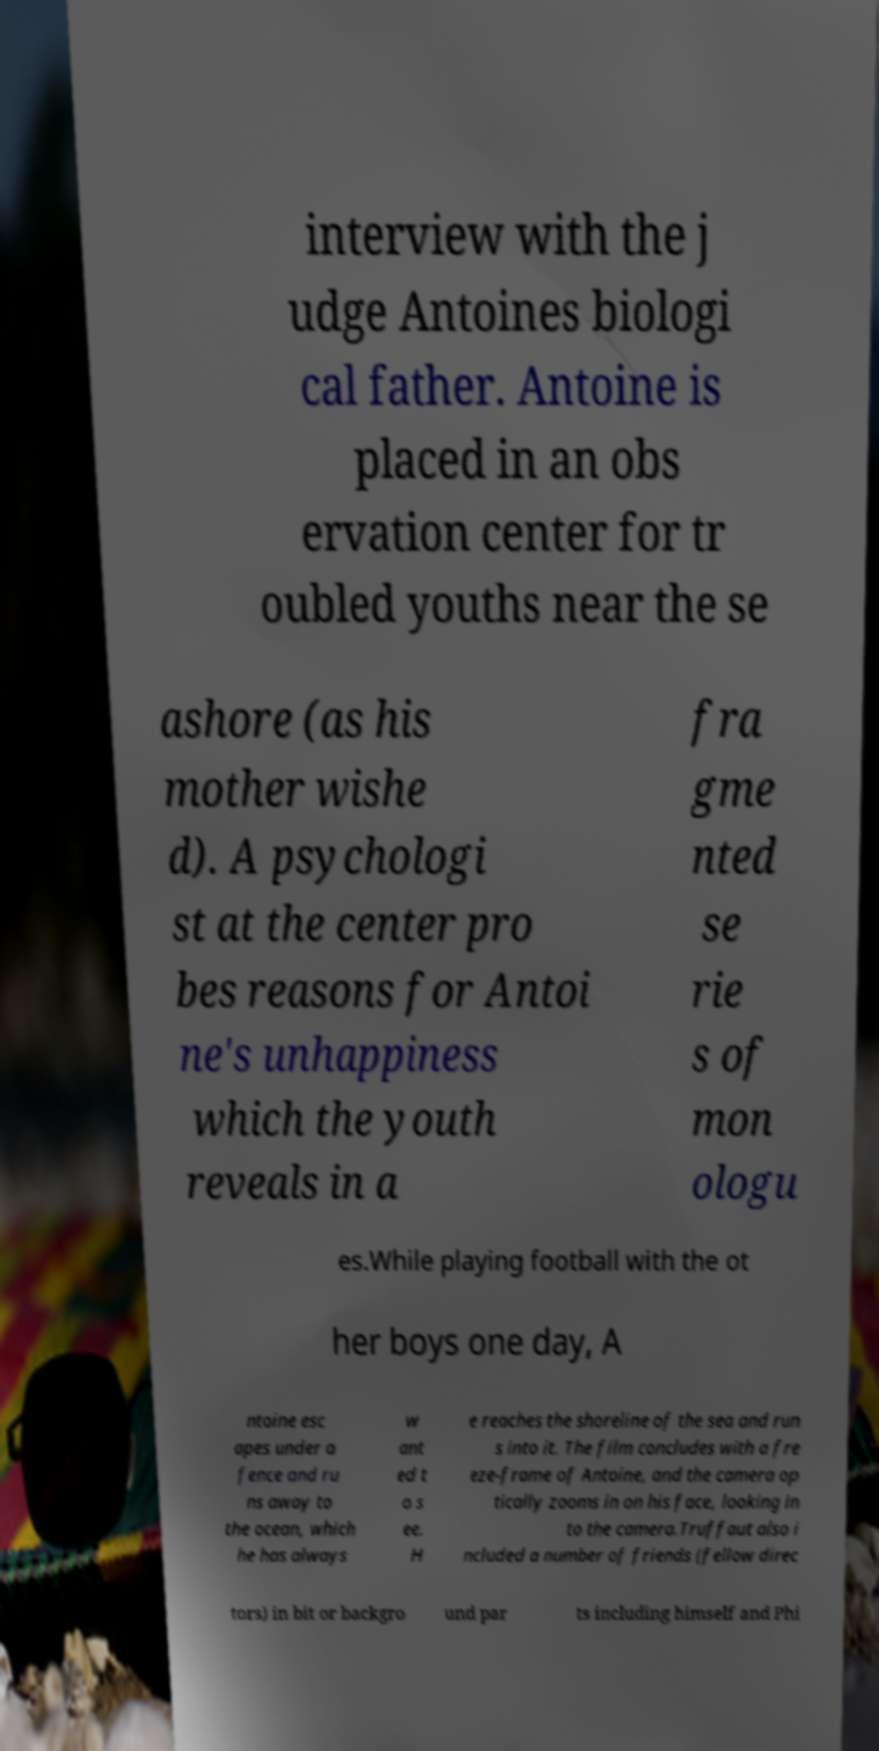There's text embedded in this image that I need extracted. Can you transcribe it verbatim? interview with the j udge Antoines biologi cal father. Antoine is placed in an obs ervation center for tr oubled youths near the se ashore (as his mother wishe d). A psychologi st at the center pro bes reasons for Antoi ne's unhappiness which the youth reveals in a fra gme nted se rie s of mon ologu es.While playing football with the ot her boys one day, A ntoine esc apes under a fence and ru ns away to the ocean, which he has always w ant ed t o s ee. H e reaches the shoreline of the sea and run s into it. The film concludes with a fre eze-frame of Antoine, and the camera op tically zooms in on his face, looking in to the camera.Truffaut also i ncluded a number of friends (fellow direc tors) in bit or backgro und par ts including himself and Phi 